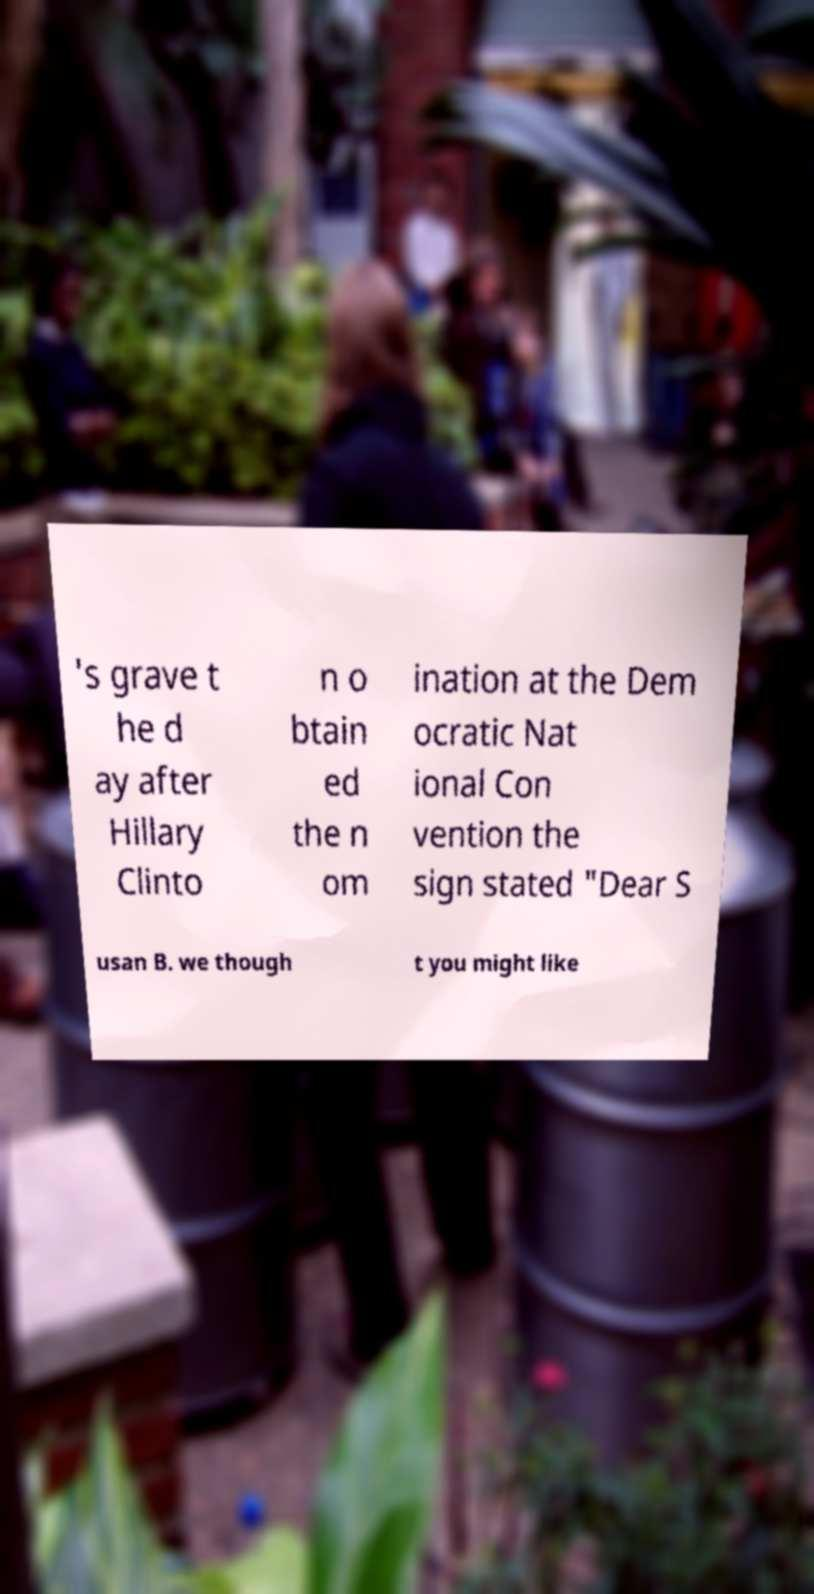Could you assist in decoding the text presented in this image and type it out clearly? 's grave t he d ay after Hillary Clinto n o btain ed the n om ination at the Dem ocratic Nat ional Con vention the sign stated "Dear S usan B. we though t you might like 